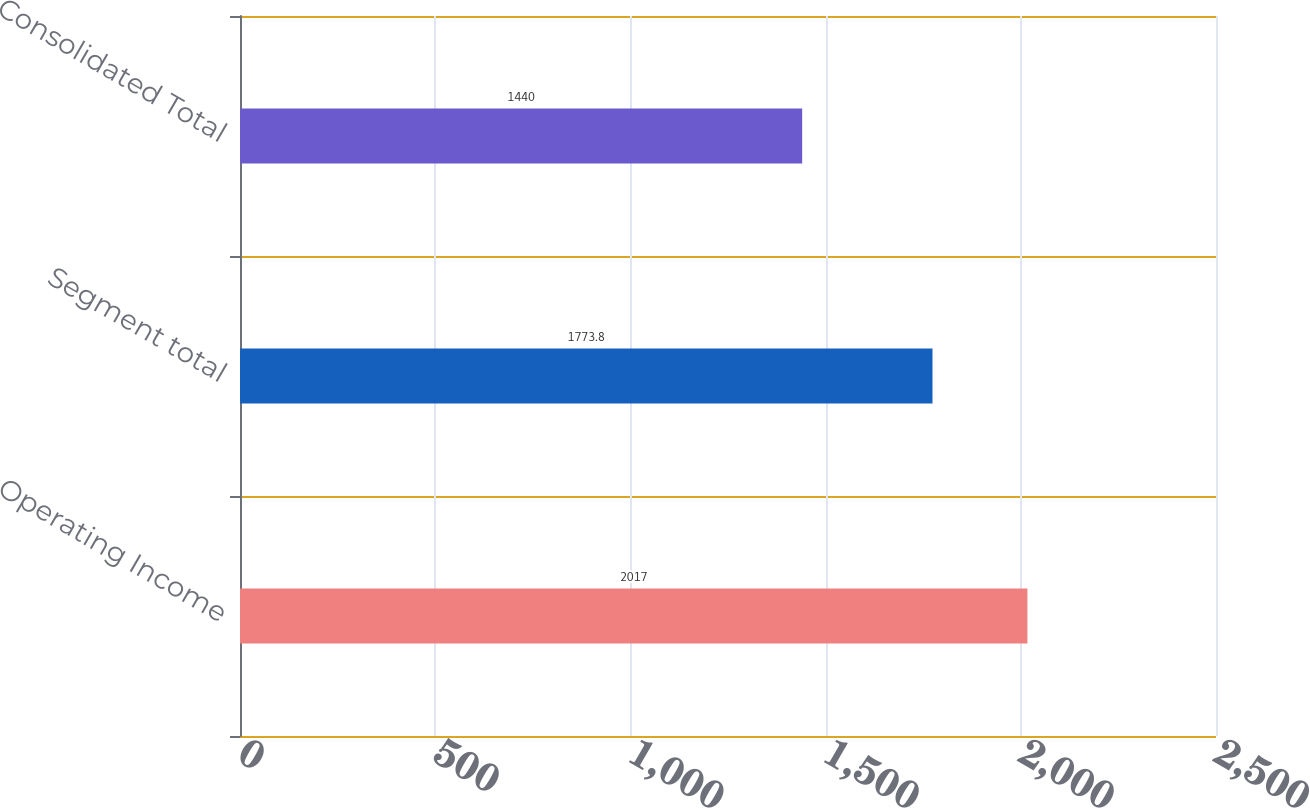<chart> <loc_0><loc_0><loc_500><loc_500><bar_chart><fcel>Operating Income<fcel>Segment total<fcel>Consolidated Total<nl><fcel>2017<fcel>1773.8<fcel>1440<nl></chart> 